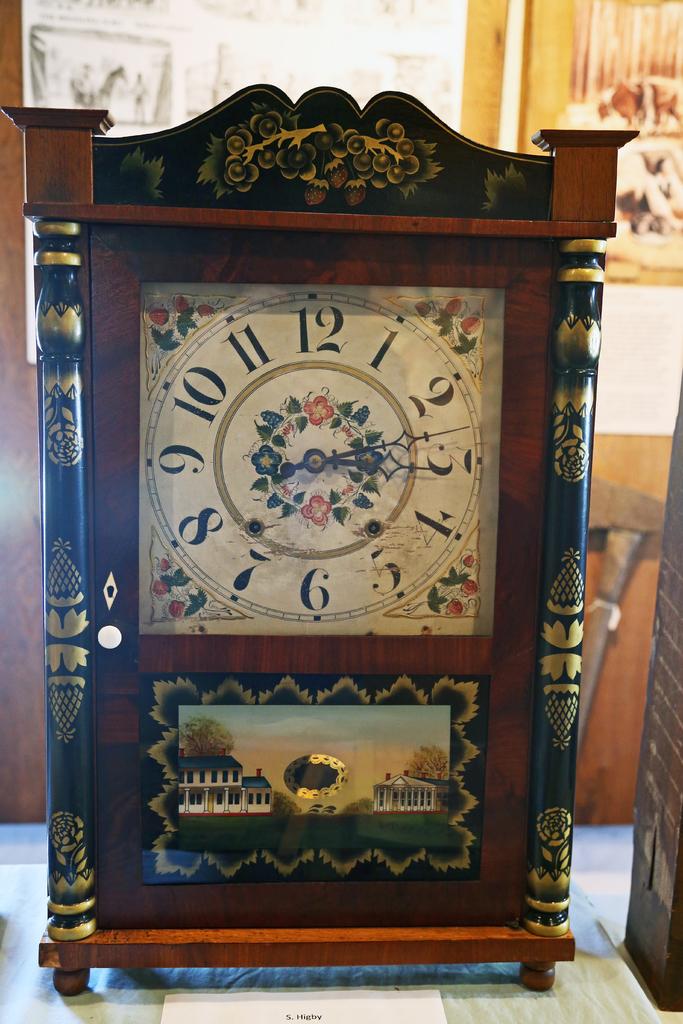What time does the clock display?
Provide a short and direct response. 3:13. Which number is the hour hand closest to?
Provide a succinct answer. 3. 